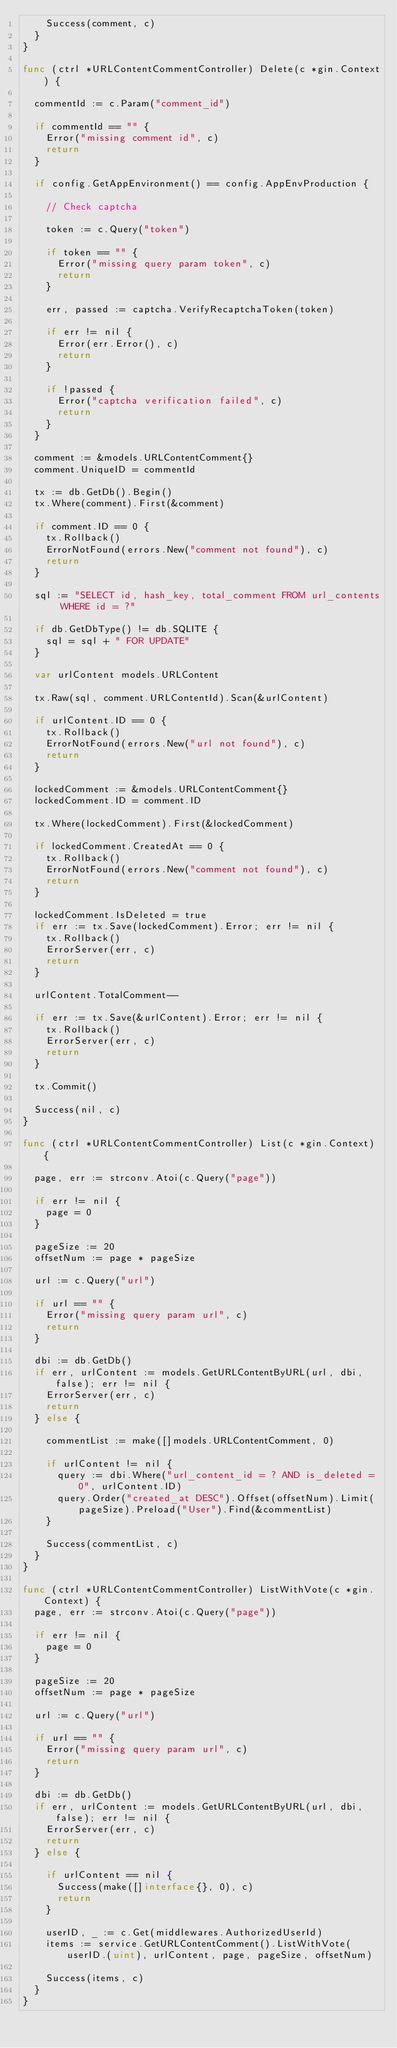Convert code to text. <code><loc_0><loc_0><loc_500><loc_500><_Go_>		Success(comment, c)
	}
}

func (ctrl *URLContentCommentController) Delete(c *gin.Context) {

	commentId := c.Param("comment_id")

	if commentId == "" {
		Error("missing comment id", c)
		return
	}

	if config.GetAppEnvironment() == config.AppEnvProduction {

		// Check captcha

		token := c.Query("token")

		if token == "" {
			Error("missing query param token", c)
			return
		}

		err, passed := captcha.VerifyRecaptchaToken(token)

		if err != nil {
			Error(err.Error(), c)
			return
		}

		if !passed {
			Error("captcha verification failed", c)
			return
		}
	}

	comment := &models.URLContentComment{}
	comment.UniqueID = commentId

	tx := db.GetDb().Begin()
	tx.Where(comment).First(&comment)

	if comment.ID == 0 {
		tx.Rollback()
		ErrorNotFound(errors.New("comment not found"), c)
		return
	}

	sql := "SELECT id, hash_key, total_comment FROM url_contents WHERE id = ?"

	if db.GetDbType() != db.SQLITE {
		sql = sql + " FOR UPDATE"
	}

	var urlContent models.URLContent

	tx.Raw(sql, comment.URLContentId).Scan(&urlContent)

	if urlContent.ID == 0 {
		tx.Rollback()
		ErrorNotFound(errors.New("url not found"), c)
		return
	}

	lockedComment := &models.URLContentComment{}
	lockedComment.ID = comment.ID

	tx.Where(lockedComment).First(&lockedComment)

	if lockedComment.CreatedAt == 0 {
		tx.Rollback()
		ErrorNotFound(errors.New("comment not found"), c)
		return
	}

	lockedComment.IsDeleted = true
	if err := tx.Save(lockedComment).Error; err != nil {
		tx.Rollback()
		ErrorServer(err, c)
		return
	}

	urlContent.TotalComment--

	if err := tx.Save(&urlContent).Error; err != nil {
		tx.Rollback()
		ErrorServer(err, c)
		return
	}

	tx.Commit()

	Success(nil, c)
}

func (ctrl *URLContentCommentController) List(c *gin.Context) {

	page, err := strconv.Atoi(c.Query("page"))

	if err != nil {
		page = 0
	}

	pageSize := 20
	offsetNum := page * pageSize

	url := c.Query("url")

	if url == "" {
		Error("missing query param url", c)
		return
	}

	dbi := db.GetDb()
	if err, urlContent := models.GetURLContentByURL(url, dbi, false); err != nil {
		ErrorServer(err, c)
		return
	} else {

		commentList := make([]models.URLContentComment, 0)

		if urlContent != nil {
			query := dbi.Where("url_content_id = ? AND is_deleted = 0", urlContent.ID)
			query.Order("created_at DESC").Offset(offsetNum).Limit(pageSize).Preload("User").Find(&commentList)
		}

		Success(commentList, c)
	}
}

func (ctrl *URLContentCommentController) ListWithVote(c *gin.Context) {
	page, err := strconv.Atoi(c.Query("page"))

	if err != nil {
		page = 0
	}

	pageSize := 20
	offsetNum := page * pageSize

	url := c.Query("url")

	if url == "" {
		Error("missing query param url", c)
		return
	}

	dbi := db.GetDb()
	if err, urlContent := models.GetURLContentByURL(url, dbi, false); err != nil {
		ErrorServer(err, c)
		return
	} else {

		if urlContent == nil {
			Success(make([]interface{}, 0), c)
			return
		}

		userID, _ := c.Get(middlewares.AuthorizedUserId)
		items := service.GetURLContentComment().ListWithVote(userID.(uint), urlContent, page, pageSize, offsetNum)

		Success(items, c)
	}
}
</code> 